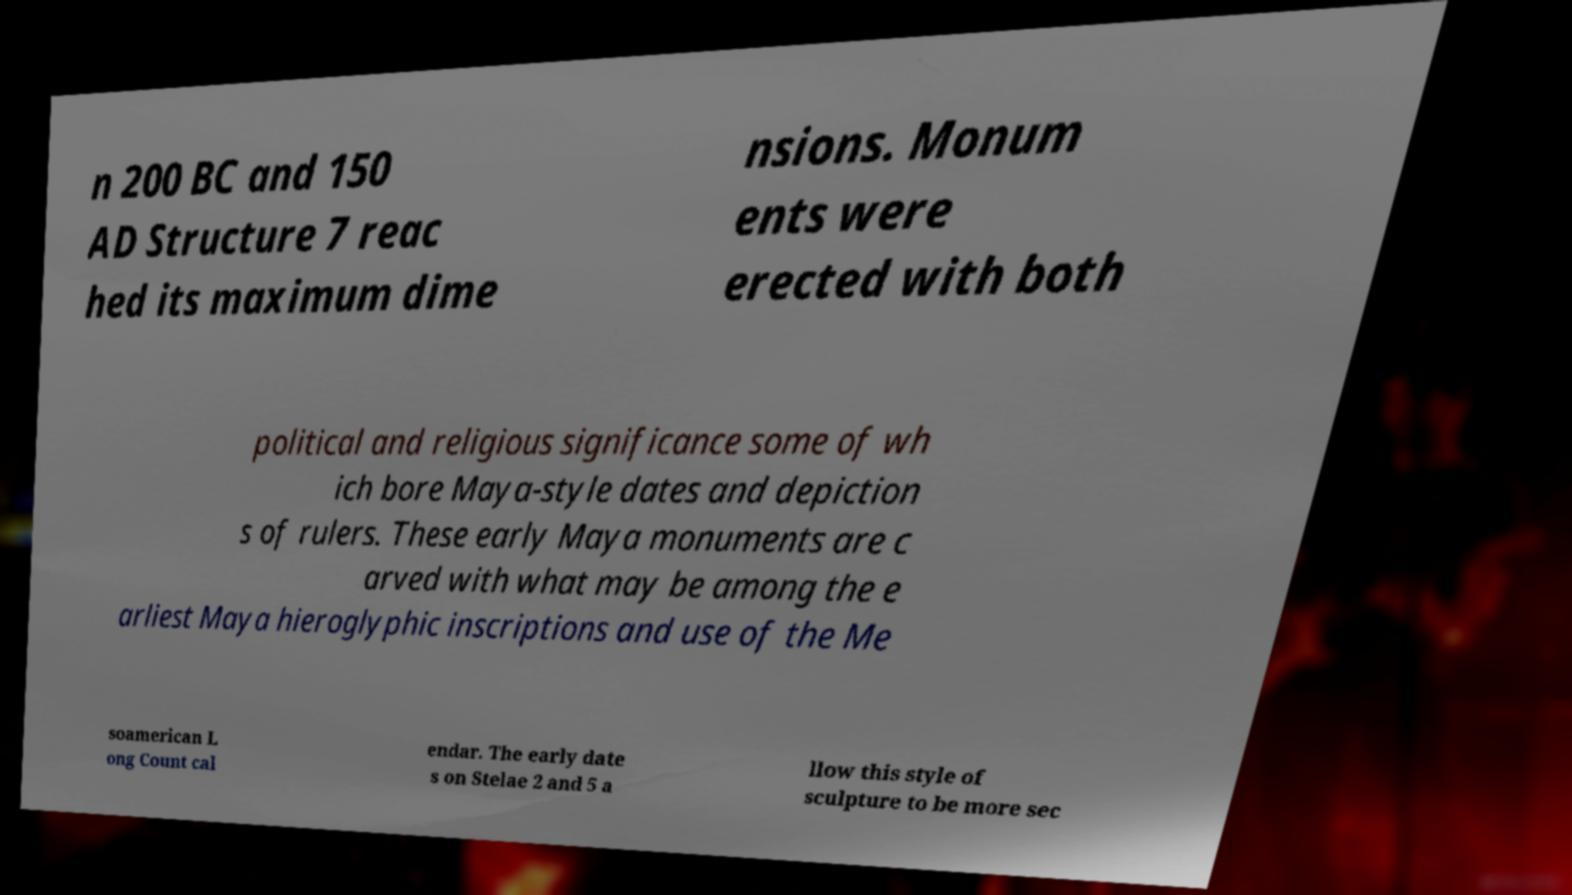Please identify and transcribe the text found in this image. n 200 BC and 150 AD Structure 7 reac hed its maximum dime nsions. Monum ents were erected with both political and religious significance some of wh ich bore Maya-style dates and depiction s of rulers. These early Maya monuments are c arved with what may be among the e arliest Maya hieroglyphic inscriptions and use of the Me soamerican L ong Count cal endar. The early date s on Stelae 2 and 5 a llow this style of sculpture to be more sec 